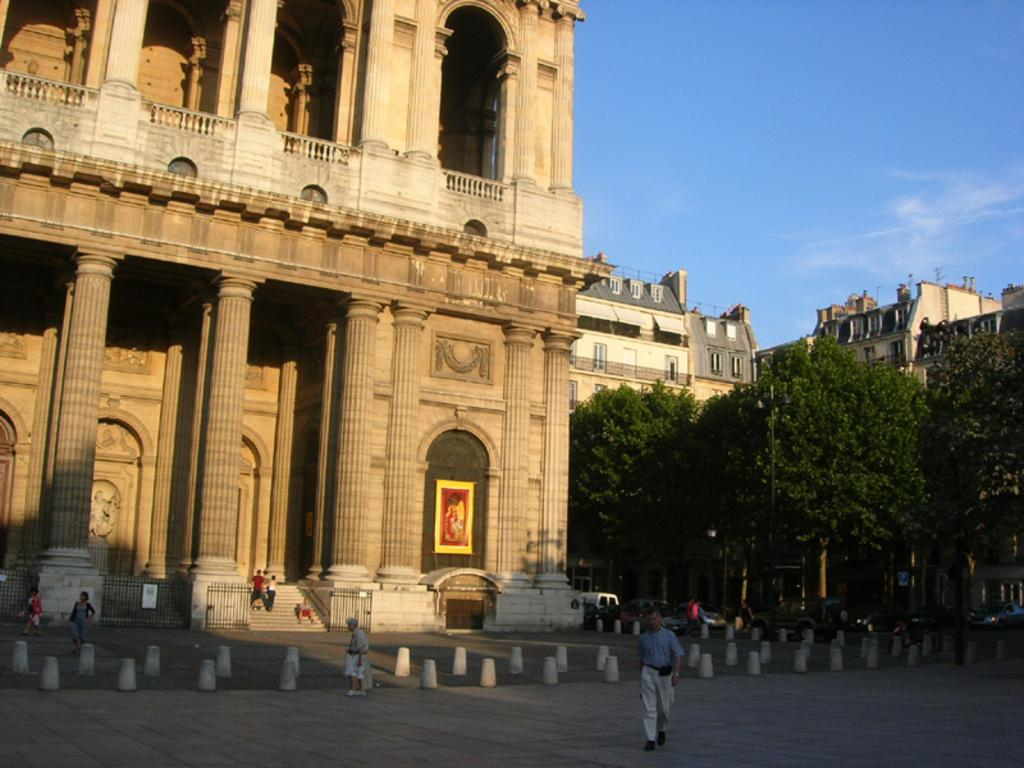What are the people at the bottom of the image doing? The people at the bottom of the image are standing and walking. What can be seen behind the people? There are trees behind the people. What else can be seen in the background of the image? There are vehicles and buildings in the background. What is visible at the top of the image? There are clouds and the sky visible at the top of the image. What is the history of the volleyball game being played in the image? There is no volleyball game present in the image, so it is not possible to discuss its history. --- Facts: 1. There is a person sitting on a chair in the image. 2. The person is holding a book. 3. There is a table next to the chair. 4. There is a lamp on the table. 5. The background of the image is dark. Absurd Topics: ocean, dance, temperature Conversation: What is the person in the image doing? The person in the image is sitting on a chair. What is the person holding while sitting on the chair? The person is holding a book. What is located next to the chair? There is a table next to the chair. What is on the table? There is a lamp on the table. What can be observed about the background of the image? The background of the image is dark. Reasoning: Let's think step by step in order to produce the conversation. We start by identifying the main subject in the image, which is the person sitting on a chair. Then, we expand the conversation to include other items that are also visible, such as the book, table, lamp, and the dark background. Each question is designed to elicit a specific detail about the image that is known from the provided facts. Absurd Question/Answer: What is the temperature of the ocean visible in the image? There is no ocean present in the image, so it is not possible to determine its temperature. --- Facts: 1. There is a person standing next to a bicycle in the image. 2. The person is wearing a helmet. 3. The bicycle has two wheels. 4. There is a road in the background. 5. The sky is visible in the background. Absurd Topics: painting, piano, flavor Conversation: What is the person in the image doing? The person in the image is standing next to a bicycle. What is the person wearing while standing next to the bicycle? The person is wearing a helmet. How many wheels does the bicycle have? The bicycle has two wheels. What can be seen in the background of the image? There is a road and the sky visible in the background. Reasoning: Let's think step by step in order to 